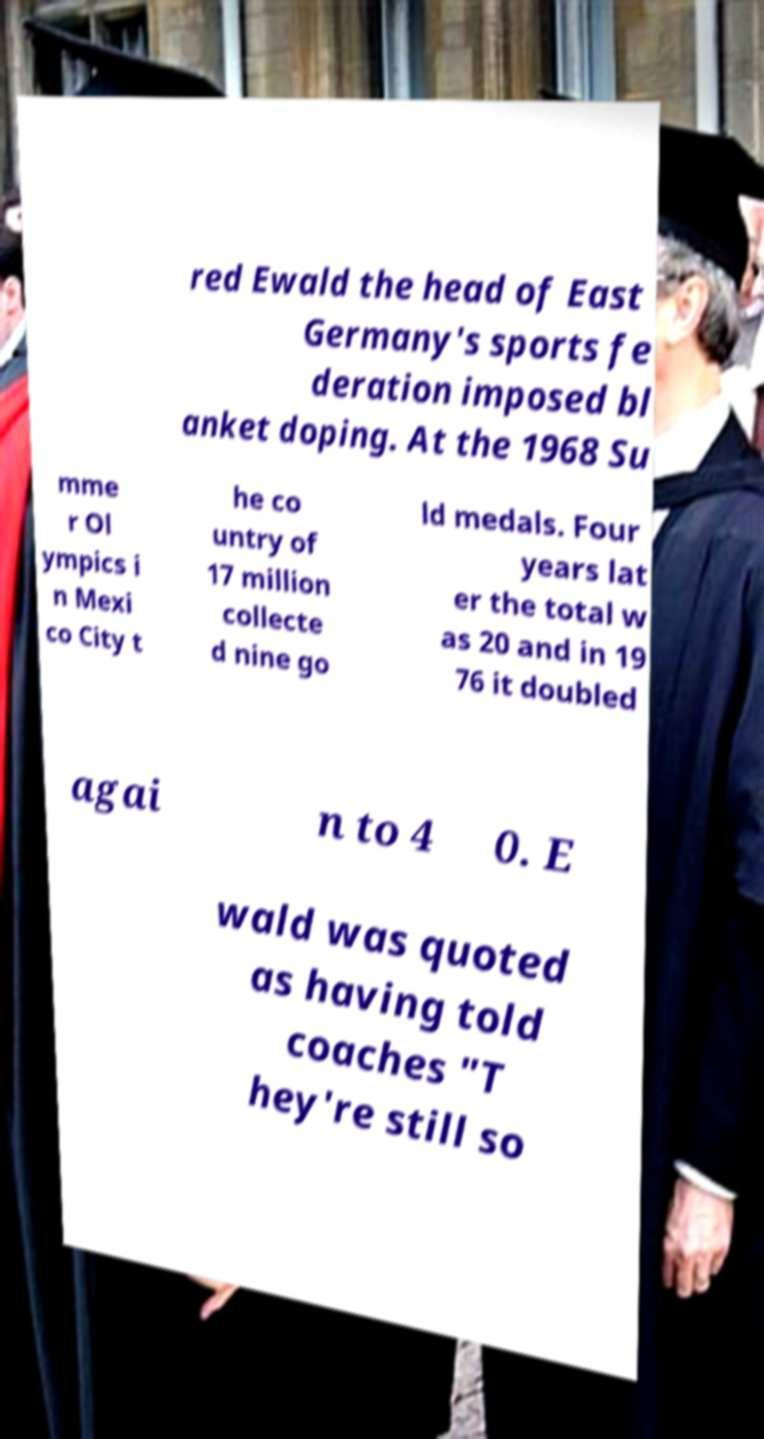Please read and relay the text visible in this image. What does it say? red Ewald the head of East Germany's sports fe deration imposed bl anket doping. At the 1968 Su mme r Ol ympics i n Mexi co City t he co untry of 17 million collecte d nine go ld medals. Four years lat er the total w as 20 and in 19 76 it doubled agai n to 4 0. E wald was quoted as having told coaches "T hey're still so 